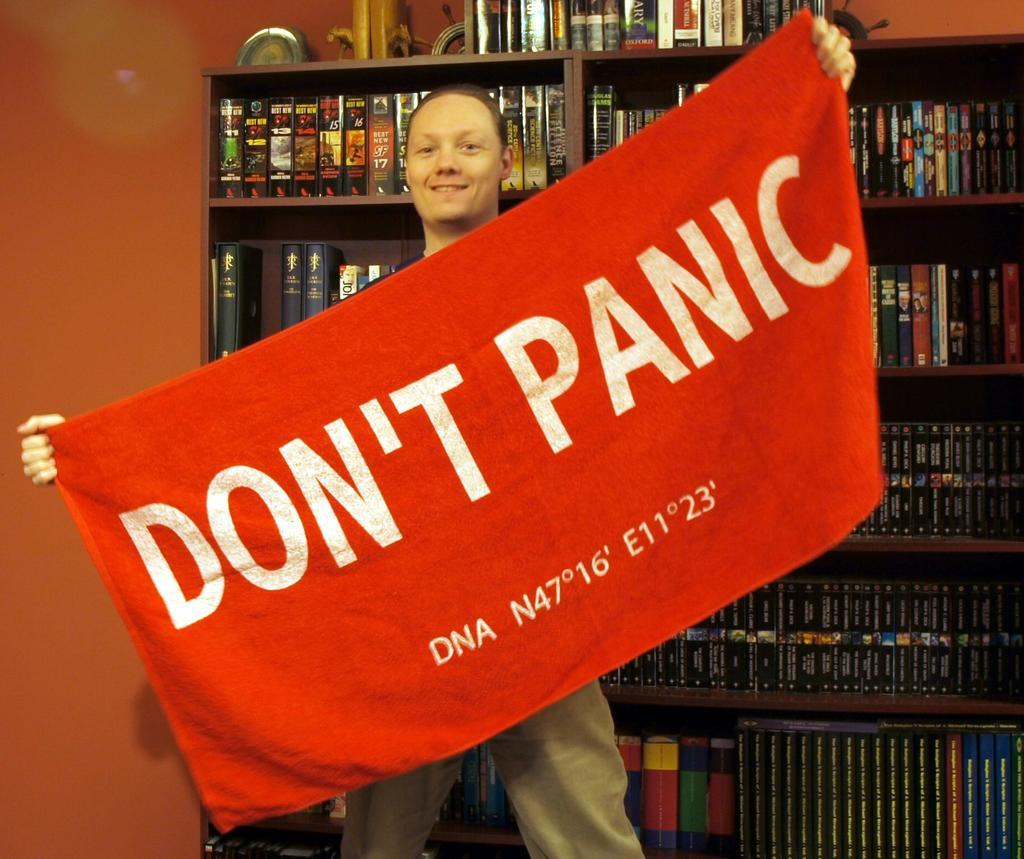Who or what is present in the image? There is a person in the image. What is the person holding in the image? The person is holding a cloth in the image. What is written on the cloth? "Don't Panic" is written on the cloth. What can be seen in the background of the image? There are shelves in the background of the image. What is on the shelves? There are many books on the shelves. How is the goat helping the person with the wound in the image? There is no goat present in the image, and no wound is mentioned or visible. 